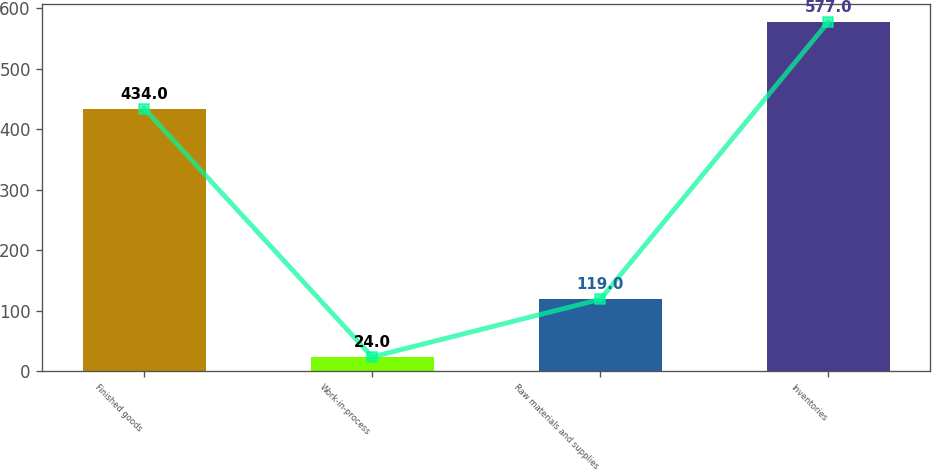Convert chart. <chart><loc_0><loc_0><loc_500><loc_500><bar_chart><fcel>Finished goods<fcel>Work-in-process<fcel>Raw materials and supplies<fcel>Inventories<nl><fcel>434<fcel>24<fcel>119<fcel>577<nl></chart> 